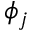Convert formula to latex. <formula><loc_0><loc_0><loc_500><loc_500>\phi _ { j }</formula> 